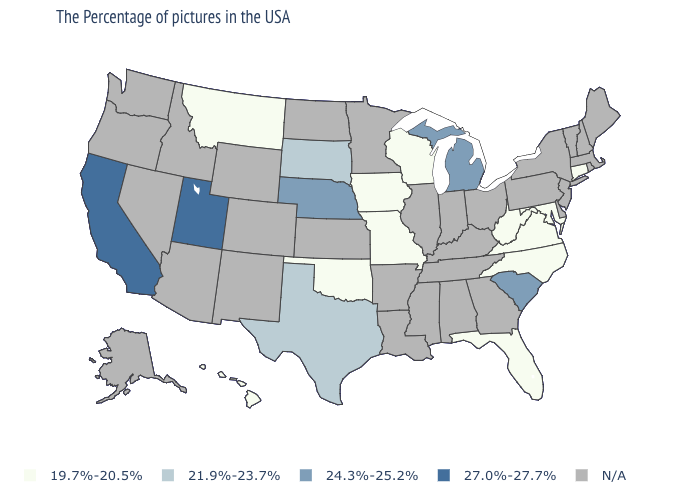Which states have the lowest value in the West?
Quick response, please. Montana, Hawaii. What is the value of California?
Give a very brief answer. 27.0%-27.7%. How many symbols are there in the legend?
Quick response, please. 5. How many symbols are there in the legend?
Keep it brief. 5. What is the lowest value in states that border Arkansas?
Give a very brief answer. 19.7%-20.5%. What is the value of Indiana?
Short answer required. N/A. Name the states that have a value in the range 24.3%-25.2%?
Be succinct. South Carolina, Michigan, Nebraska. Name the states that have a value in the range 21.9%-23.7%?
Short answer required. Texas, South Dakota. Name the states that have a value in the range N/A?
Keep it brief. Maine, Massachusetts, Rhode Island, New Hampshire, Vermont, New York, New Jersey, Delaware, Pennsylvania, Ohio, Georgia, Kentucky, Indiana, Alabama, Tennessee, Illinois, Mississippi, Louisiana, Arkansas, Minnesota, Kansas, North Dakota, Wyoming, Colorado, New Mexico, Arizona, Idaho, Nevada, Washington, Oregon, Alaska. What is the lowest value in the USA?
Short answer required. 19.7%-20.5%. What is the value of New York?
Answer briefly. N/A. Among the states that border Wisconsin , which have the highest value?
Keep it brief. Michigan. 